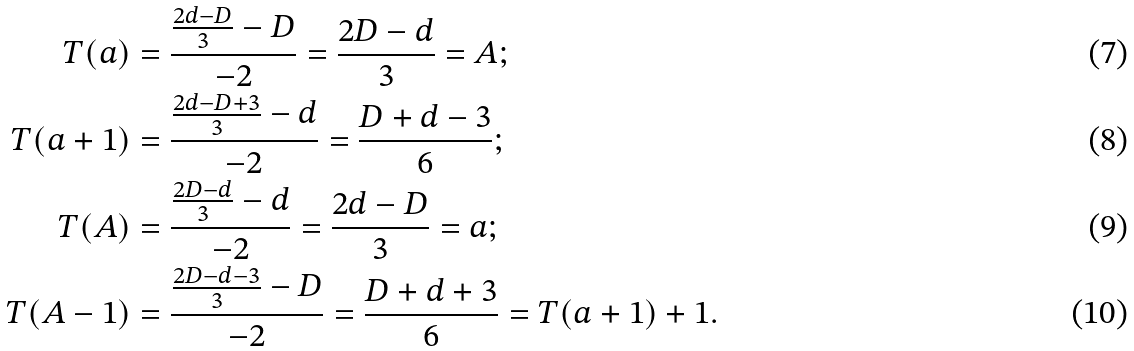<formula> <loc_0><loc_0><loc_500><loc_500>T ( a ) & = \frac { \frac { 2 d - D } 3 - D } { - 2 } = \frac { 2 D - d } 3 = A ; \\ T ( a + 1 ) & = \frac { \frac { 2 d - D + 3 } 3 - d } { - 2 } = \frac { D + d - 3 } 6 ; \\ T ( A ) & = \frac { \frac { 2 D - d } 3 - d } { - 2 } = \frac { 2 d - D } 3 = a ; \\ T ( A - 1 ) & = \frac { \frac { 2 D - d - 3 } 3 - D } { - 2 } = \frac { D + d + 3 } 6 = T ( a + 1 ) + 1 .</formula> 